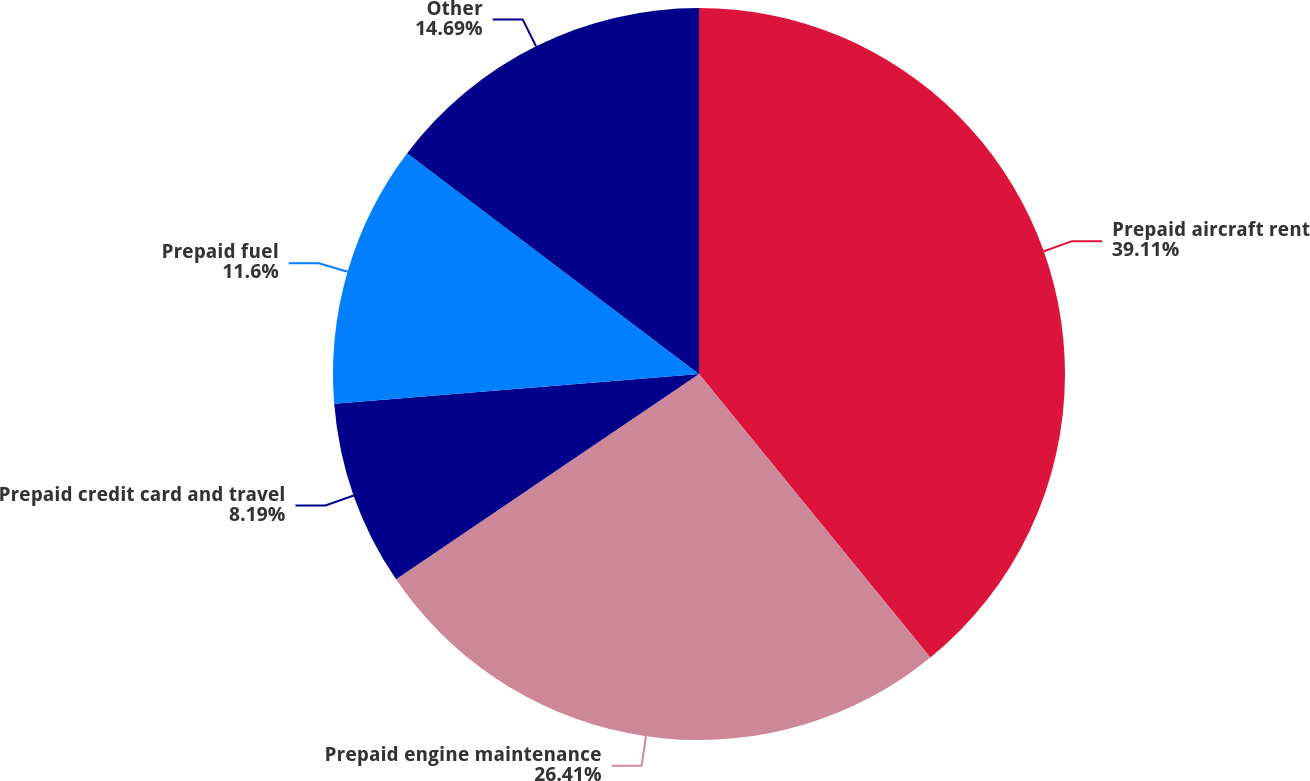Convert chart to OTSL. <chart><loc_0><loc_0><loc_500><loc_500><pie_chart><fcel>Prepaid aircraft rent<fcel>Prepaid engine maintenance<fcel>Prepaid credit card and travel<fcel>Prepaid fuel<fcel>Other<nl><fcel>39.11%<fcel>26.41%<fcel>8.19%<fcel>11.6%<fcel>14.69%<nl></chart> 